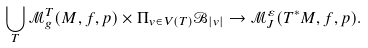Convert formula to latex. <formula><loc_0><loc_0><loc_500><loc_500>\bigcup _ { T } \mathcal { M } _ { g } ^ { T } ( M , f , p ) \times \Pi _ { v \in V ( T ) } \mathcal { B } _ { | v | } \rightarrow \mathcal { M } _ { J } ^ { \varepsilon } ( T ^ { * } M , f , p ) .</formula> 